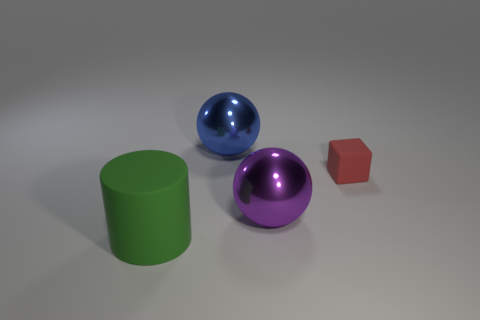How would you describe the lighting and shadow effects in this scene? The lighting in the scene is soft and diffused, originating from the upper left. This creates gentle shadows on the right side of the objects, allowing for subtle depth and dimensionality without harsh contrasts. 